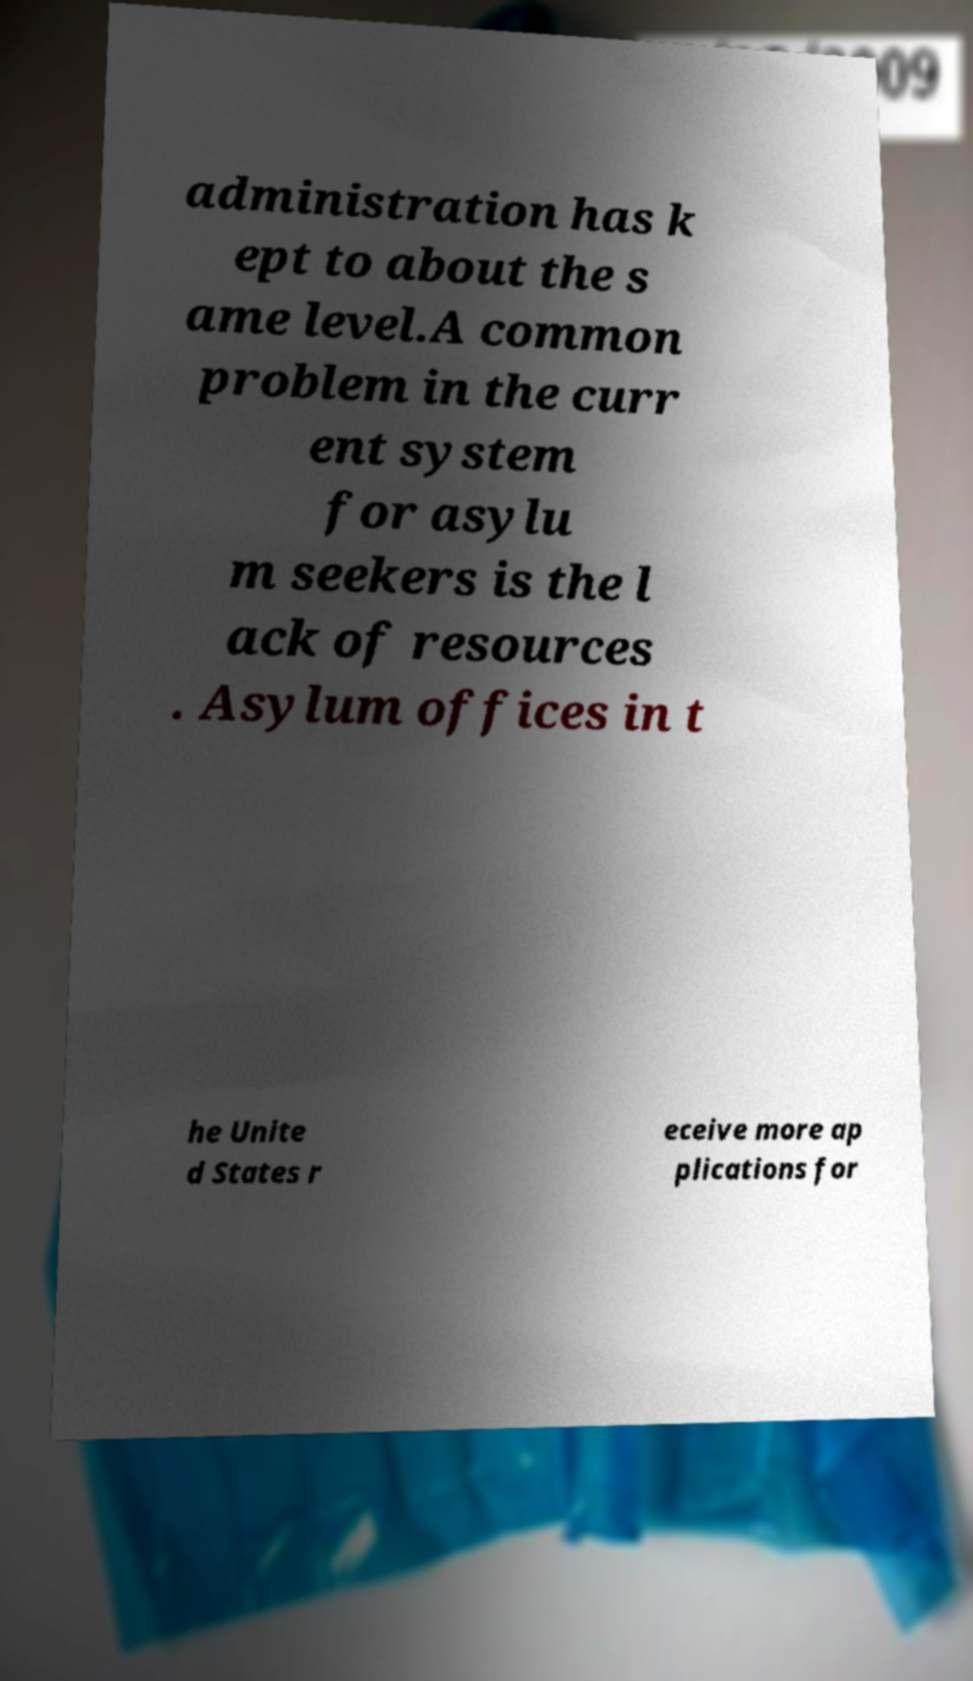Please read and relay the text visible in this image. What does it say? administration has k ept to about the s ame level.A common problem in the curr ent system for asylu m seekers is the l ack of resources . Asylum offices in t he Unite d States r eceive more ap plications for 